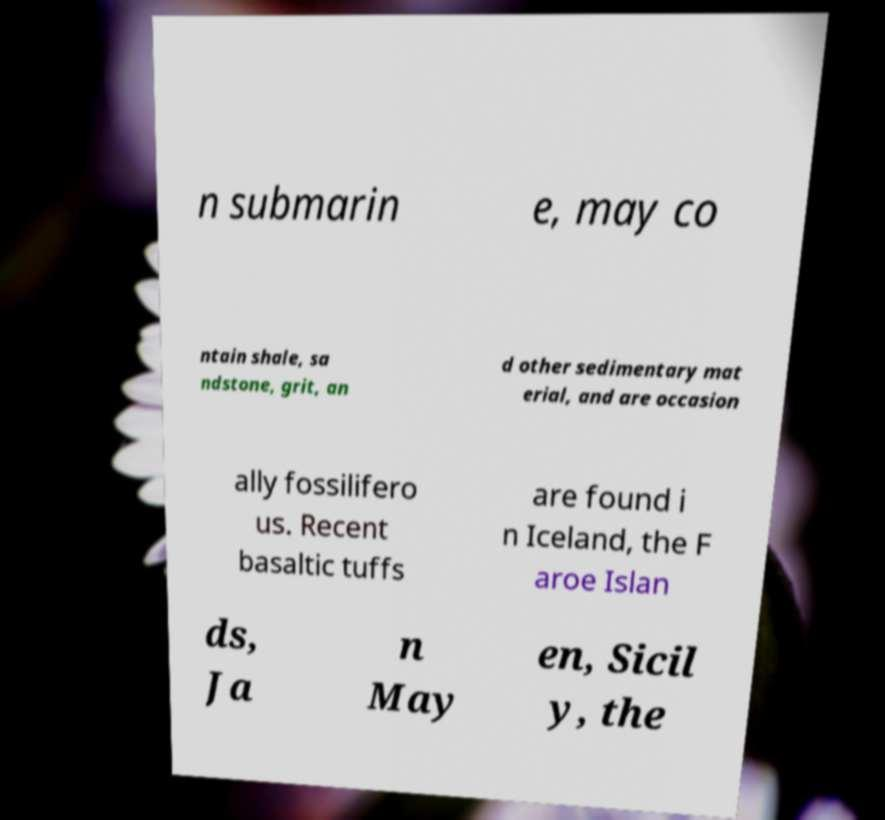Can you accurately transcribe the text from the provided image for me? n submarin e, may co ntain shale, sa ndstone, grit, an d other sedimentary mat erial, and are occasion ally fossilifero us. Recent basaltic tuffs are found i n Iceland, the F aroe Islan ds, Ja n May en, Sicil y, the 